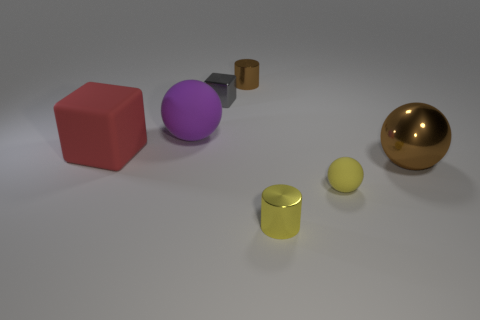Add 1 large red matte spheres. How many objects exist? 8 Subtract all cylinders. How many objects are left? 5 Subtract all shiny balls. Subtract all purple things. How many objects are left? 5 Add 4 big purple objects. How many big purple objects are left? 5 Add 3 yellow balls. How many yellow balls exist? 4 Subtract 1 yellow spheres. How many objects are left? 6 